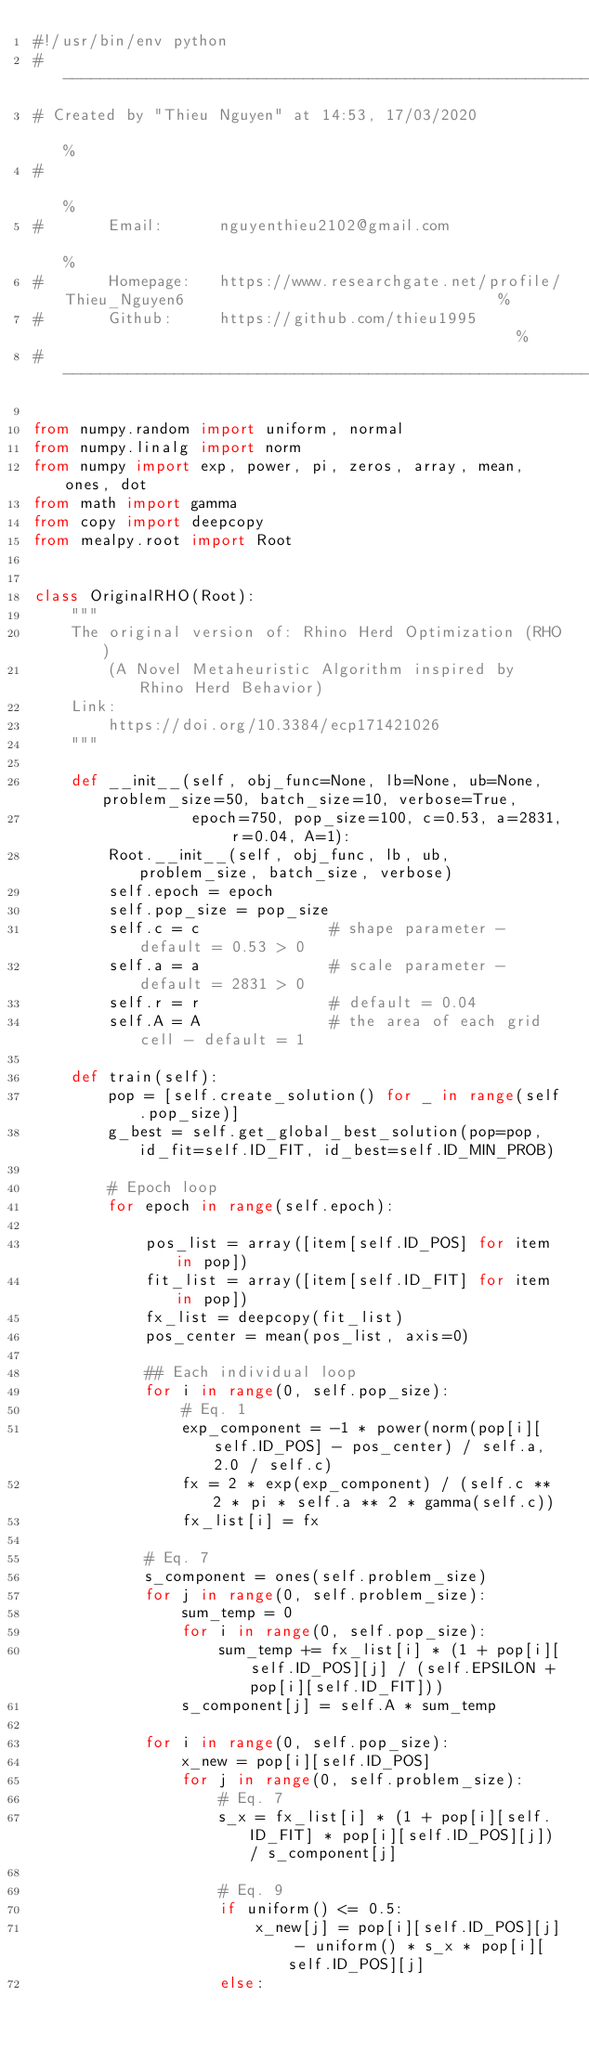Convert code to text. <code><loc_0><loc_0><loc_500><loc_500><_Python_>#!/usr/bin/env python
# ------------------------------------------------------------------------------------------------------%
# Created by "Thieu Nguyen" at 14:53, 17/03/2020                                                        %
#                                                                                                       %
#       Email:      nguyenthieu2102@gmail.com                                                           %
#       Homepage:   https://www.researchgate.net/profile/Thieu_Nguyen6                                  %
#       Github:     https://github.com/thieu1995                                                  %
#-------------------------------------------------------------------------------------------------------%

from numpy.random import uniform, normal
from numpy.linalg import norm
from numpy import exp, power, pi, zeros, array, mean, ones, dot
from math import gamma
from copy import deepcopy
from mealpy.root import Root


class OriginalRHO(Root):
    """
    The original version of: Rhino Herd Optimization (RHO)
        (A Novel Metaheuristic Algorithm inspired by Rhino Herd Behavior)
    Link:
        https://doi.org/10.3384/ecp171421026
    """

    def __init__(self, obj_func=None, lb=None, ub=None, problem_size=50, batch_size=10, verbose=True,
                 epoch=750, pop_size=100, c=0.53, a=2831, r=0.04, A=1):
        Root.__init__(self, obj_func, lb, ub, problem_size, batch_size, verbose)
        self.epoch = epoch
        self.pop_size = pop_size
        self.c = c              # shape parameter - default = 0.53 > 0
        self.a = a              # scale parameter - default = 2831 > 0
        self.r = r              # default = 0.04
        self.A = A              # the area of each grid cell - default = 1

    def train(self):
        pop = [self.create_solution() for _ in range(self.pop_size)]
        g_best = self.get_global_best_solution(pop=pop, id_fit=self.ID_FIT, id_best=self.ID_MIN_PROB)

        # Epoch loop
        for epoch in range(self.epoch):

            pos_list = array([item[self.ID_POS] for item in pop])
            fit_list = array([item[self.ID_FIT] for item in pop])
            fx_list = deepcopy(fit_list)
            pos_center = mean(pos_list, axis=0)

            ## Each individual loop
            for i in range(0, self.pop_size):
                # Eq. 1
                exp_component = -1 * power(norm(pop[i][self.ID_POS] - pos_center) / self.a, 2.0 / self.c)
                fx = 2 * exp(exp_component) / (self.c ** 2 * pi * self.a ** 2 * gamma(self.c))
                fx_list[i] = fx

            # Eq. 7
            s_component = ones(self.problem_size)
            for j in range(0, self.problem_size):
                sum_temp = 0
                for i in range(0, self.pop_size):
                    sum_temp += fx_list[i] * (1 + pop[i][self.ID_POS][j] / (self.EPSILON + pop[i][self.ID_FIT]))
                s_component[j] = self.A * sum_temp

            for i in range(0, self.pop_size):
                x_new = pop[i][self.ID_POS]
                for j in range(0, self.problem_size):
                    # Eq. 7
                    s_x = fx_list[i] * (1 + pop[i][self.ID_FIT] * pop[i][self.ID_POS][j]) / s_component[j]

                    # Eq. 9
                    if uniform() <= 0.5:
                        x_new[j] = pop[i][self.ID_POS][j] - uniform() * s_x * pop[i][self.ID_POS][j]
                    else:</code> 